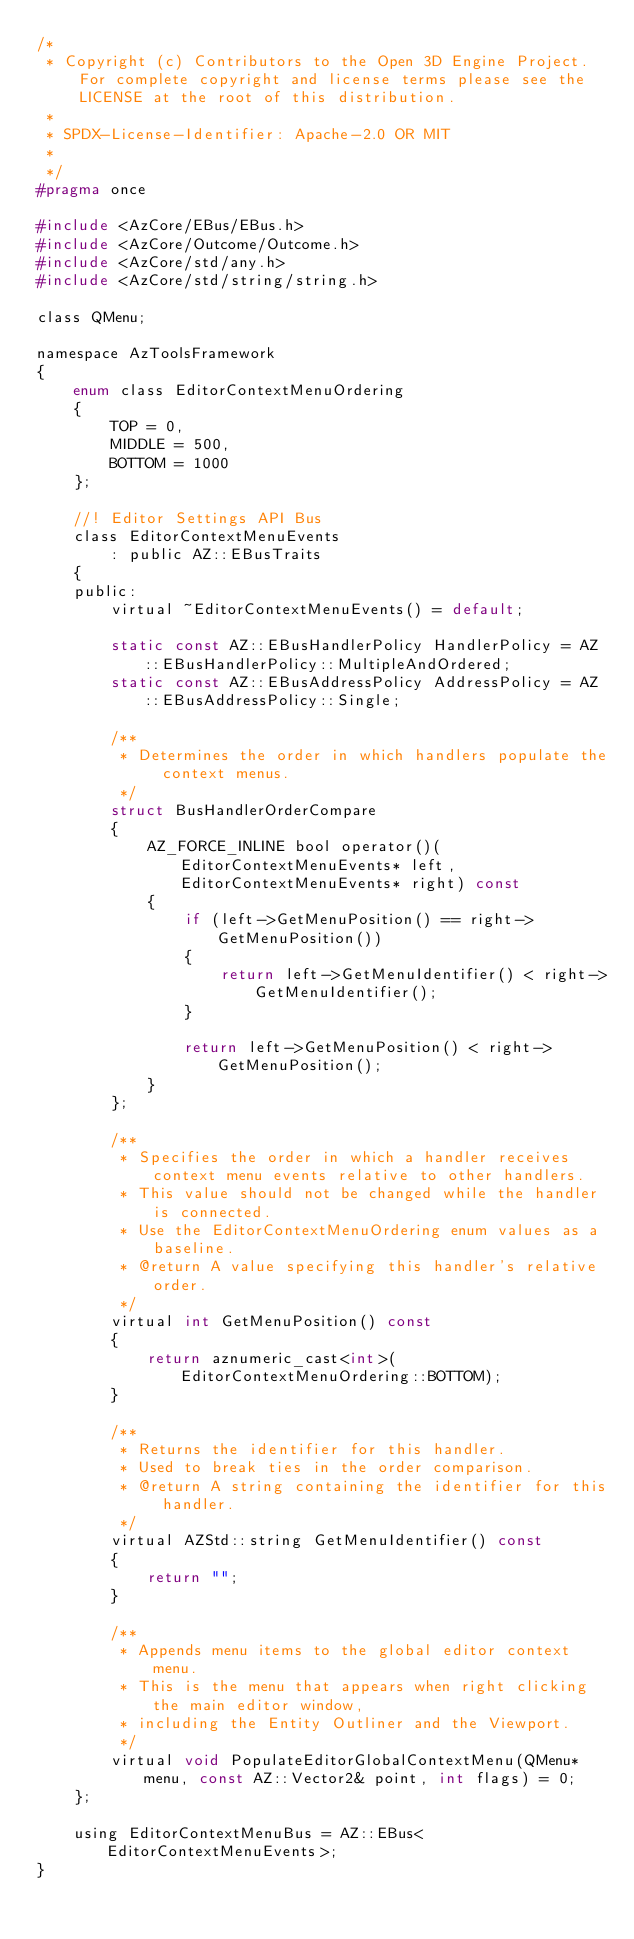<code> <loc_0><loc_0><loc_500><loc_500><_C_>/*
 * Copyright (c) Contributors to the Open 3D Engine Project. For complete copyright and license terms please see the LICENSE at the root of this distribution.
 * 
 * SPDX-License-Identifier: Apache-2.0 OR MIT
 *
 */
#pragma once

#include <AzCore/EBus/EBus.h>
#include <AzCore/Outcome/Outcome.h>
#include <AzCore/std/any.h>
#include <AzCore/std/string/string.h>

class QMenu;

namespace AzToolsFramework
{
    enum class EditorContextMenuOrdering
    {
        TOP = 0,
        MIDDLE = 500,
        BOTTOM = 1000
    };

    //! Editor Settings API Bus
    class EditorContextMenuEvents
        : public AZ::EBusTraits
    {
    public:
        virtual ~EditorContextMenuEvents() = default;

        static const AZ::EBusHandlerPolicy HandlerPolicy = AZ::EBusHandlerPolicy::MultipleAndOrdered;
        static const AZ::EBusAddressPolicy AddressPolicy = AZ::EBusAddressPolicy::Single;
        
        /**
         * Determines the order in which handlers populate the context menus.
         */
        struct BusHandlerOrderCompare
        {
            AZ_FORCE_INLINE bool operator()(EditorContextMenuEvents* left, EditorContextMenuEvents* right) const
            {
                if (left->GetMenuPosition() == right->GetMenuPosition())
                {
                    return left->GetMenuIdentifier() < right->GetMenuIdentifier();
                }

                return left->GetMenuPosition() < right->GetMenuPosition();
            }
        };

        /**
         * Specifies the order in which a handler receives context menu events relative to other handlers.
         * This value should not be changed while the handler is connected.
         * Use the EditorContextMenuOrdering enum values as a baseline.
         * @return A value specifying this handler's relative order.
         */
        virtual int GetMenuPosition() const
        {
            return aznumeric_cast<int>(EditorContextMenuOrdering::BOTTOM);
        }

        /**
         * Returns the identifier for this handler.
         * Used to break ties in the order comparison.
         * @return A string containing the identifier for this handler.
         */
        virtual AZStd::string GetMenuIdentifier() const
        {
            return "";
        }

        /**
         * Appends menu items to the global editor context menu.
         * This is the menu that appears when right clicking the main editor window,
         * including the Entity Outliner and the Viewport.
         */
        virtual void PopulateEditorGlobalContextMenu(QMenu* menu, const AZ::Vector2& point, int flags) = 0;
    };

    using EditorContextMenuBus = AZ::EBus<EditorContextMenuEvents>;
}
</code> 